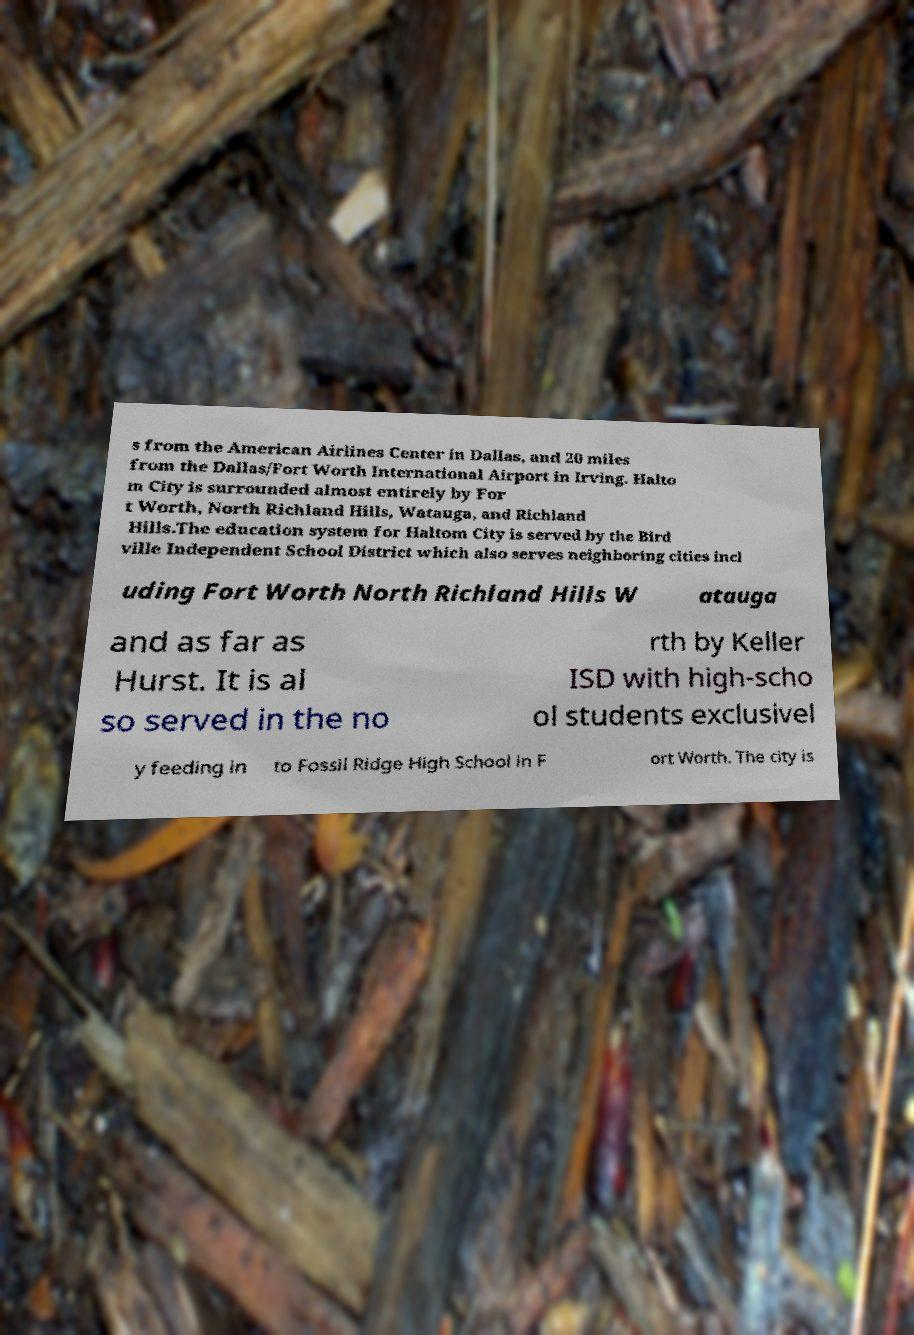For documentation purposes, I need the text within this image transcribed. Could you provide that? s from the American Airlines Center in Dallas, and 20 miles from the Dallas/Fort Worth International Airport in Irving. Halto m City is surrounded almost entirely by For t Worth, North Richland Hills, Watauga, and Richland Hills.The education system for Haltom City is served by the Bird ville Independent School District which also serves neighboring cities incl uding Fort Worth North Richland Hills W atauga and as far as Hurst. It is al so served in the no rth by Keller ISD with high-scho ol students exclusivel y feeding in to Fossil Ridge High School in F ort Worth. The city is 